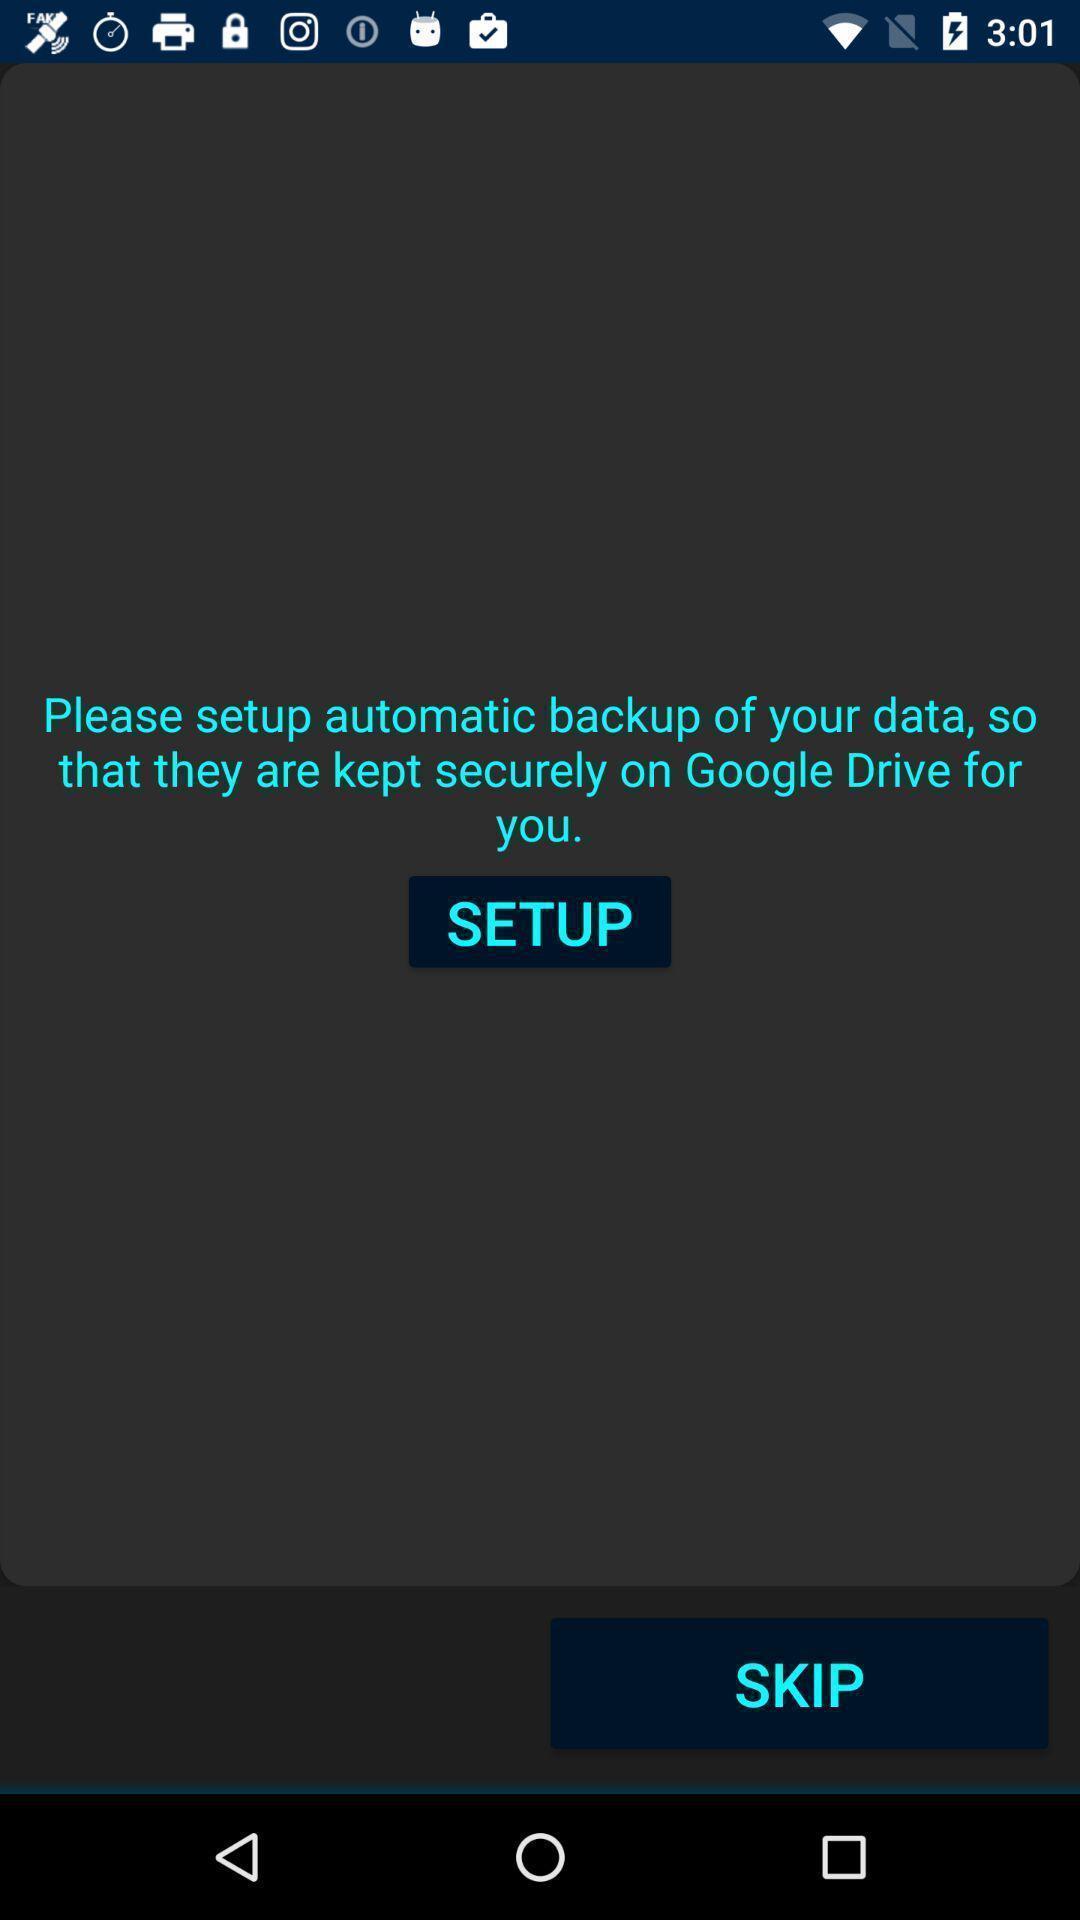Describe the key features of this screenshot. Welcome page for an app. 